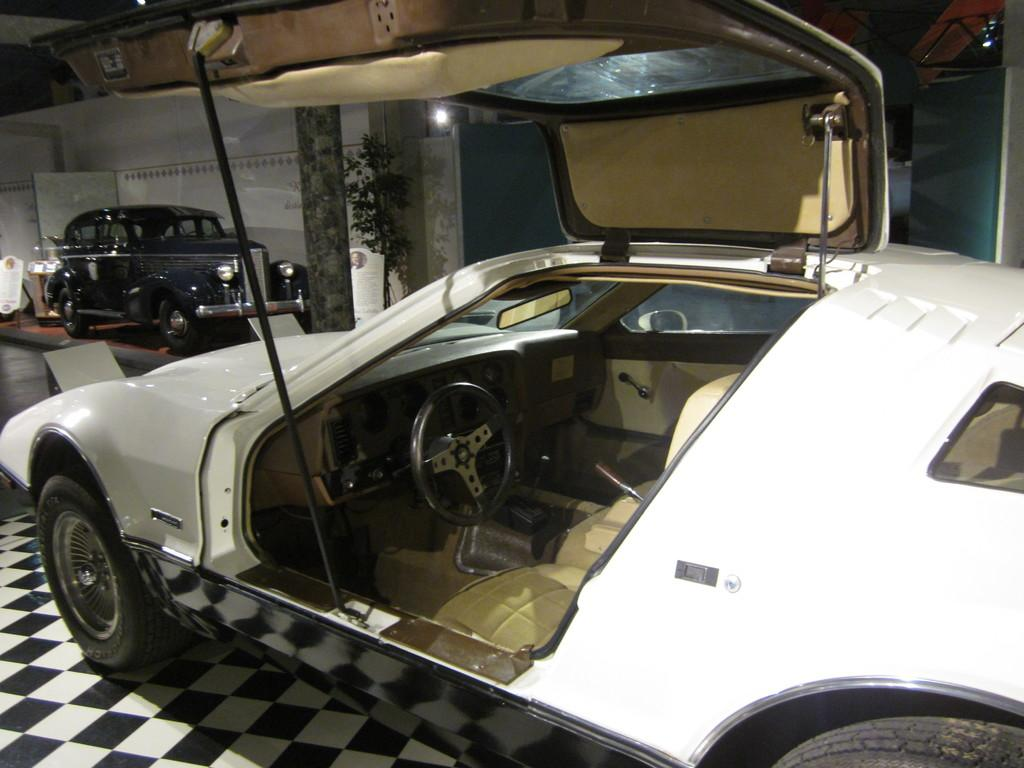How many cars are present in the image? There are two cars in the image. Where are the cars located? The cars are placed on the floor. What is the condition of one of the car doors? One car has its door open. What type of vegetation can be seen in the image? There is a plant visible in the image. What is the background of the image? There is a wall visible in the image. What type of furniture is visible in the image? There is no furniture present in the image. How does the fog affect the visibility of the cars in the image? There is no fog present in the image, so it does not affect the visibility of the cars. 